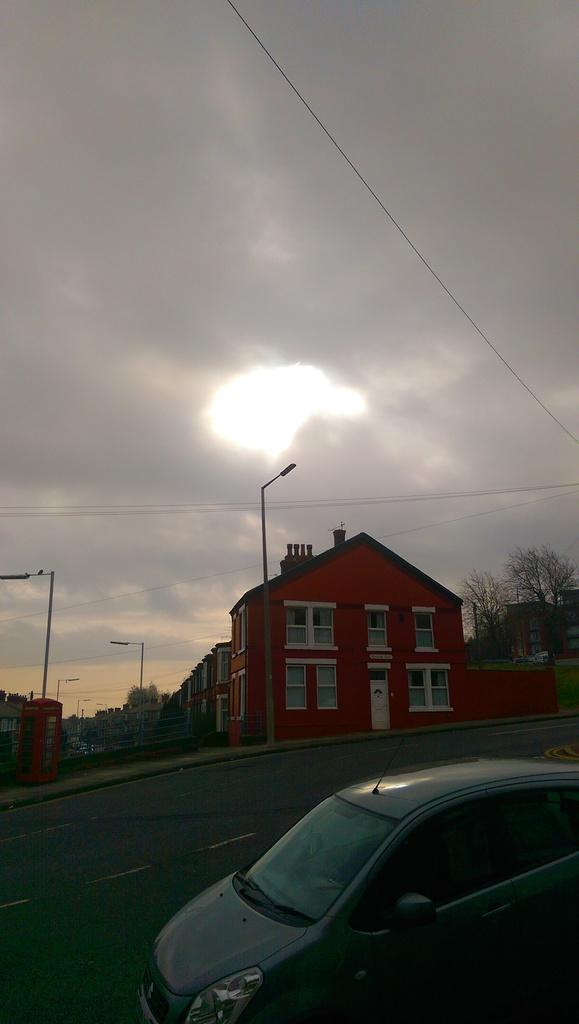What is the main subject of the image? There is a car on the road in the image. What can be seen in the background of the image? The sky with clouds is visible in the background of the image. What type of structures are present in the image? There are buildings with windows in the image. What other objects can be seen in the image? There are trees and poles in the image. What type of stone is being used to support the car in the image? There is no stone present in the image to support the car; it is on the road. How many legs does the car have in the image? Cars do not have legs; they have wheels. In the image, the car has four wheels. 